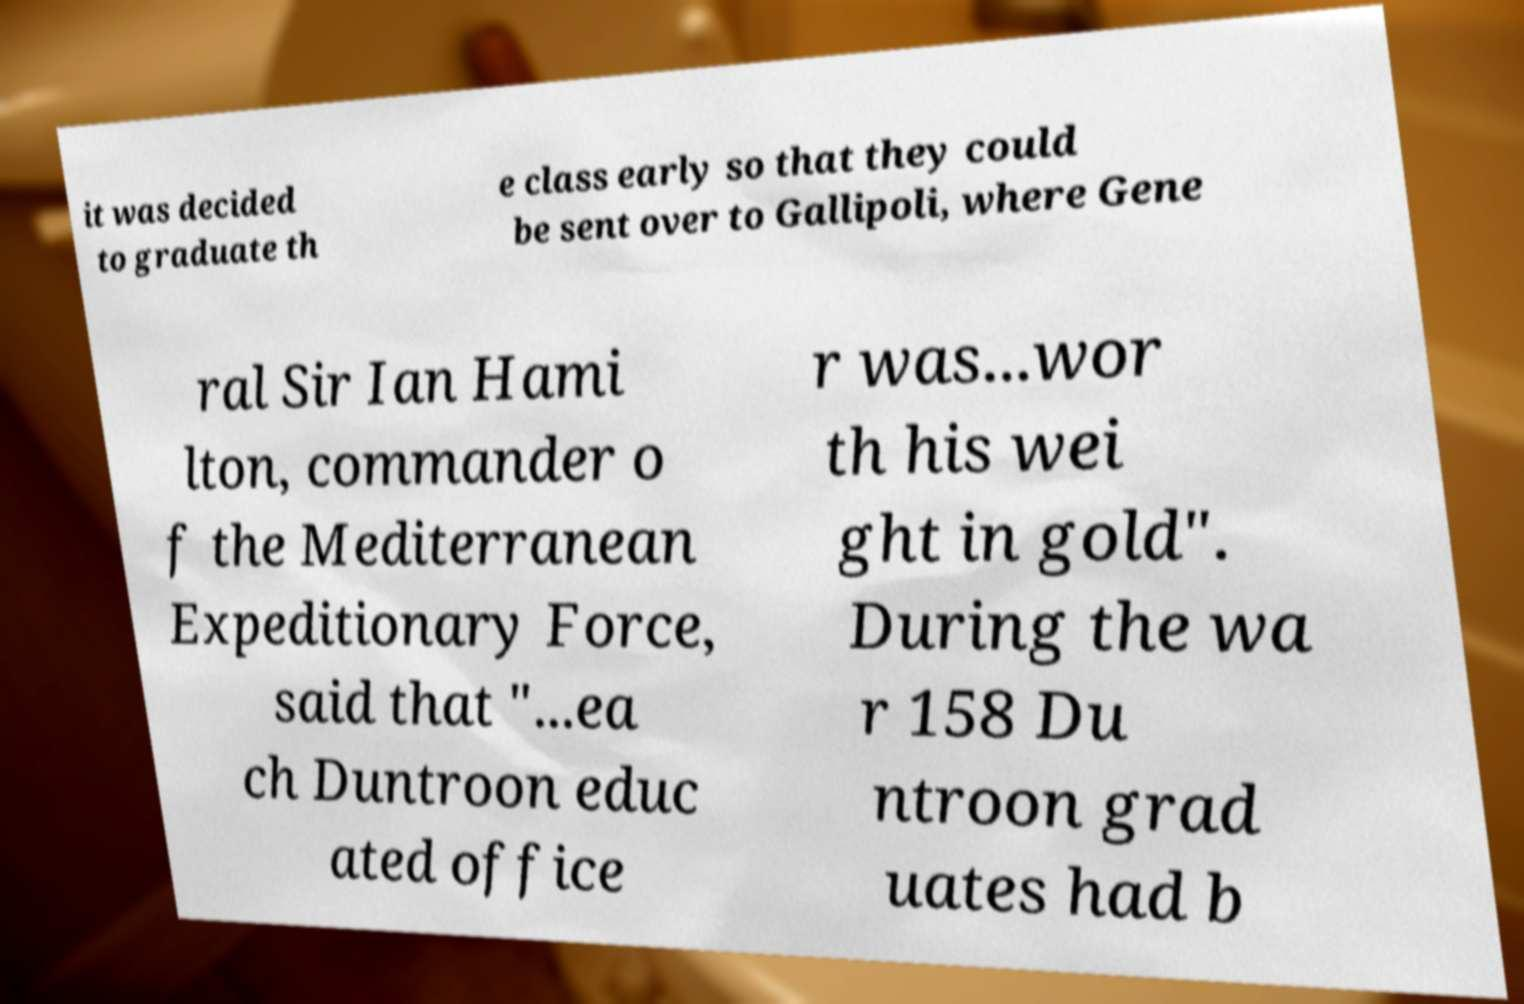For documentation purposes, I need the text within this image transcribed. Could you provide that? it was decided to graduate th e class early so that they could be sent over to Gallipoli, where Gene ral Sir Ian Hami lton, commander o f the Mediterranean Expeditionary Force, said that "...ea ch Duntroon educ ated office r was...wor th his wei ght in gold". During the wa r 158 Du ntroon grad uates had b 